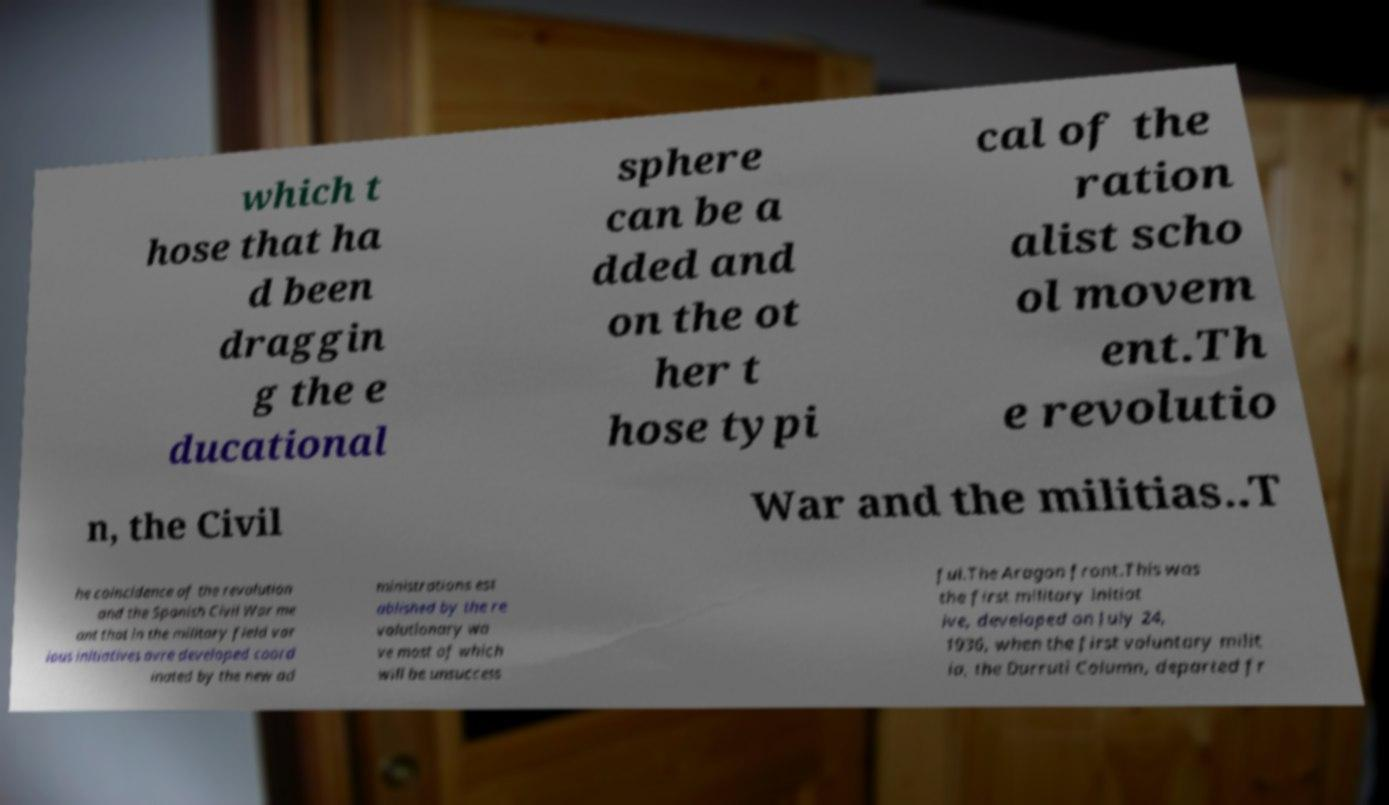For documentation purposes, I need the text within this image transcribed. Could you provide that? which t hose that ha d been draggin g the e ducational sphere can be a dded and on the ot her t hose typi cal of the ration alist scho ol movem ent.Th e revolutio n, the Civil War and the militias..T he coincidence of the revolution and the Spanish Civil War me ant that in the military field var ious initiatives avre developed coord inated by the new ad ministrations est ablished by the re volutionary wa ve most of which will be unsuccess ful.The Aragon front.This was the first military initiat ive, developed on July 24, 1936, when the first voluntary milit ia, the Durruti Column, departed fr 